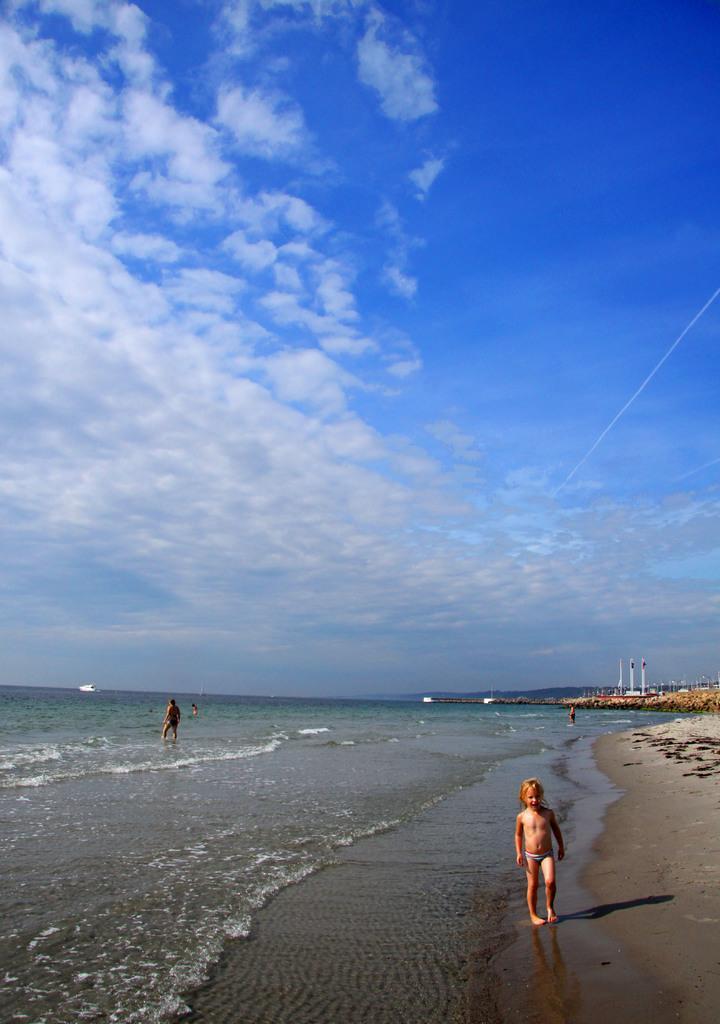Describe this image in one or two sentences. In this image we can see a beach with some persons and there is a sky with clouds. 